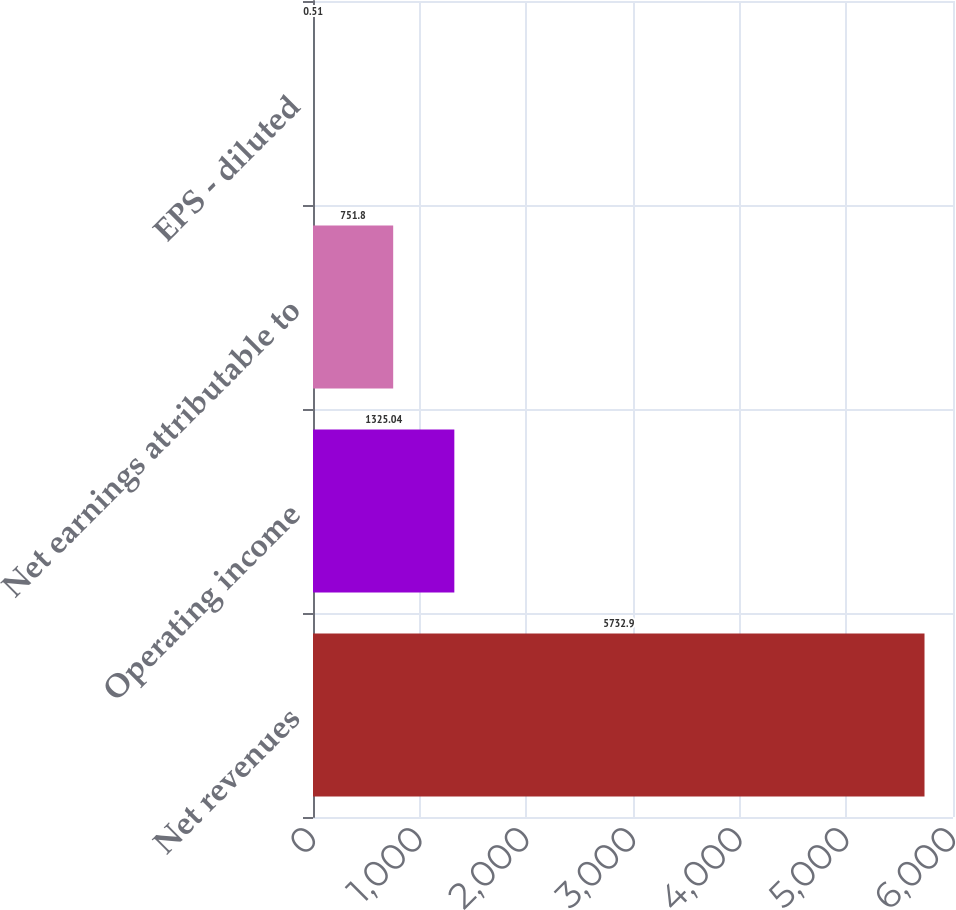Convert chart to OTSL. <chart><loc_0><loc_0><loc_500><loc_500><bar_chart><fcel>Net revenues<fcel>Operating income<fcel>Net earnings attributable to<fcel>EPS - diluted<nl><fcel>5732.9<fcel>1325.04<fcel>751.8<fcel>0.51<nl></chart> 